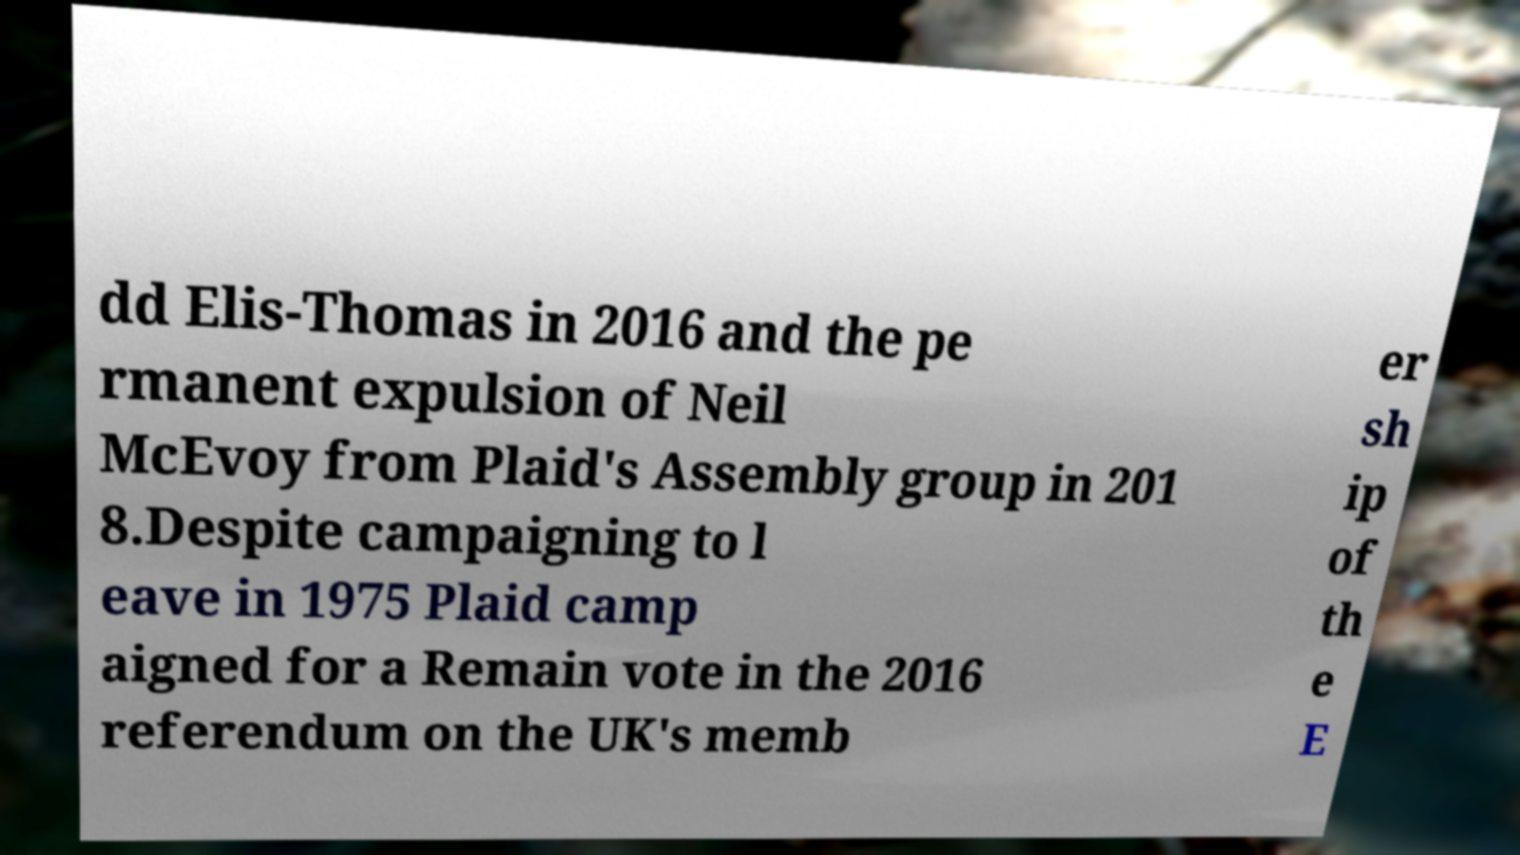Please identify and transcribe the text found in this image. dd Elis-Thomas in 2016 and the pe rmanent expulsion of Neil McEvoy from Plaid's Assembly group in 201 8.Despite campaigning to l eave in 1975 Plaid camp aigned for a Remain vote in the 2016 referendum on the UK's memb er sh ip of th e E 